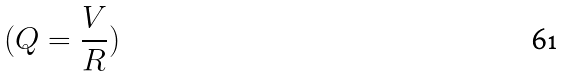Convert formula to latex. <formula><loc_0><loc_0><loc_500><loc_500>( Q = \frac { V } { R } )</formula> 